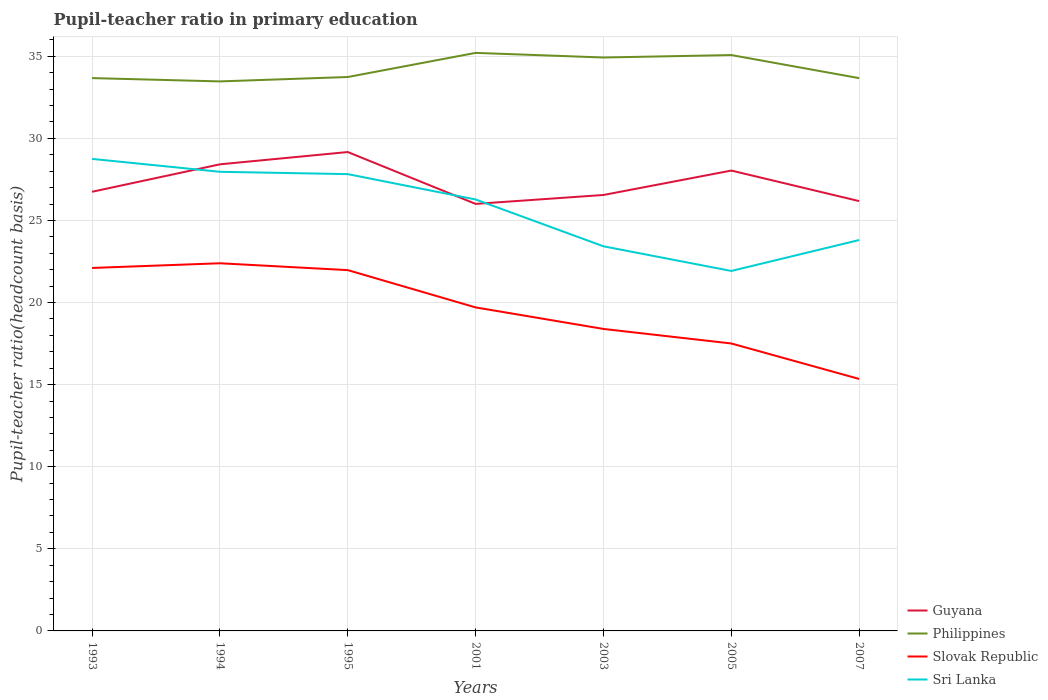Is the number of lines equal to the number of legend labels?
Ensure brevity in your answer.  Yes. Across all years, what is the maximum pupil-teacher ratio in primary education in Philippines?
Provide a short and direct response. 33.47. In which year was the pupil-teacher ratio in primary education in Philippines maximum?
Provide a short and direct response. 1994. What is the total pupil-teacher ratio in primary education in Guyana in the graph?
Your answer should be very brief. 0.19. What is the difference between the highest and the second highest pupil-teacher ratio in primary education in Sri Lanka?
Offer a very short reply. 6.83. What is the difference between the highest and the lowest pupil-teacher ratio in primary education in Philippines?
Ensure brevity in your answer.  3. Does the graph contain any zero values?
Offer a very short reply. No. Does the graph contain grids?
Provide a short and direct response. Yes. How are the legend labels stacked?
Give a very brief answer. Vertical. What is the title of the graph?
Provide a short and direct response. Pupil-teacher ratio in primary education. Does "Bahamas" appear as one of the legend labels in the graph?
Keep it short and to the point. No. What is the label or title of the Y-axis?
Your answer should be compact. Pupil-teacher ratio(headcount basis). What is the Pupil-teacher ratio(headcount basis) of Guyana in 1993?
Your answer should be very brief. 26.75. What is the Pupil-teacher ratio(headcount basis) of Philippines in 1993?
Ensure brevity in your answer.  33.67. What is the Pupil-teacher ratio(headcount basis) in Slovak Republic in 1993?
Offer a terse response. 22.11. What is the Pupil-teacher ratio(headcount basis) in Sri Lanka in 1993?
Provide a succinct answer. 28.75. What is the Pupil-teacher ratio(headcount basis) of Guyana in 1994?
Provide a succinct answer. 28.42. What is the Pupil-teacher ratio(headcount basis) in Philippines in 1994?
Your answer should be compact. 33.47. What is the Pupil-teacher ratio(headcount basis) of Slovak Republic in 1994?
Give a very brief answer. 22.39. What is the Pupil-teacher ratio(headcount basis) of Sri Lanka in 1994?
Give a very brief answer. 27.96. What is the Pupil-teacher ratio(headcount basis) of Guyana in 1995?
Offer a terse response. 29.17. What is the Pupil-teacher ratio(headcount basis) of Philippines in 1995?
Make the answer very short. 33.74. What is the Pupil-teacher ratio(headcount basis) of Slovak Republic in 1995?
Provide a succinct answer. 21.98. What is the Pupil-teacher ratio(headcount basis) of Sri Lanka in 1995?
Your answer should be compact. 27.82. What is the Pupil-teacher ratio(headcount basis) of Guyana in 2001?
Make the answer very short. 26.01. What is the Pupil-teacher ratio(headcount basis) of Philippines in 2001?
Ensure brevity in your answer.  35.21. What is the Pupil-teacher ratio(headcount basis) of Slovak Republic in 2001?
Give a very brief answer. 19.7. What is the Pupil-teacher ratio(headcount basis) in Sri Lanka in 2001?
Offer a very short reply. 26.28. What is the Pupil-teacher ratio(headcount basis) in Guyana in 2003?
Offer a terse response. 26.55. What is the Pupil-teacher ratio(headcount basis) of Philippines in 2003?
Your answer should be compact. 34.93. What is the Pupil-teacher ratio(headcount basis) of Slovak Republic in 2003?
Your response must be concise. 18.39. What is the Pupil-teacher ratio(headcount basis) in Sri Lanka in 2003?
Your answer should be compact. 23.43. What is the Pupil-teacher ratio(headcount basis) in Guyana in 2005?
Give a very brief answer. 28.04. What is the Pupil-teacher ratio(headcount basis) of Philippines in 2005?
Make the answer very short. 35.07. What is the Pupil-teacher ratio(headcount basis) in Slovak Republic in 2005?
Provide a succinct answer. 17.51. What is the Pupil-teacher ratio(headcount basis) in Sri Lanka in 2005?
Provide a succinct answer. 21.92. What is the Pupil-teacher ratio(headcount basis) of Guyana in 2007?
Ensure brevity in your answer.  26.18. What is the Pupil-teacher ratio(headcount basis) in Philippines in 2007?
Provide a short and direct response. 33.67. What is the Pupil-teacher ratio(headcount basis) in Slovak Republic in 2007?
Make the answer very short. 15.35. What is the Pupil-teacher ratio(headcount basis) of Sri Lanka in 2007?
Give a very brief answer. 23.81. Across all years, what is the maximum Pupil-teacher ratio(headcount basis) in Guyana?
Offer a terse response. 29.17. Across all years, what is the maximum Pupil-teacher ratio(headcount basis) in Philippines?
Offer a very short reply. 35.21. Across all years, what is the maximum Pupil-teacher ratio(headcount basis) of Slovak Republic?
Offer a very short reply. 22.39. Across all years, what is the maximum Pupil-teacher ratio(headcount basis) of Sri Lanka?
Keep it short and to the point. 28.75. Across all years, what is the minimum Pupil-teacher ratio(headcount basis) in Guyana?
Provide a short and direct response. 26.01. Across all years, what is the minimum Pupil-teacher ratio(headcount basis) in Philippines?
Your answer should be very brief. 33.47. Across all years, what is the minimum Pupil-teacher ratio(headcount basis) in Slovak Republic?
Your response must be concise. 15.35. Across all years, what is the minimum Pupil-teacher ratio(headcount basis) in Sri Lanka?
Keep it short and to the point. 21.92. What is the total Pupil-teacher ratio(headcount basis) in Guyana in the graph?
Your answer should be compact. 191.11. What is the total Pupil-teacher ratio(headcount basis) in Philippines in the graph?
Provide a succinct answer. 239.75. What is the total Pupil-teacher ratio(headcount basis) of Slovak Republic in the graph?
Provide a short and direct response. 137.43. What is the total Pupil-teacher ratio(headcount basis) in Sri Lanka in the graph?
Make the answer very short. 179.97. What is the difference between the Pupil-teacher ratio(headcount basis) of Guyana in 1993 and that in 1994?
Give a very brief answer. -1.67. What is the difference between the Pupil-teacher ratio(headcount basis) in Philippines in 1993 and that in 1994?
Your answer should be compact. 0.2. What is the difference between the Pupil-teacher ratio(headcount basis) of Slovak Republic in 1993 and that in 1994?
Your answer should be very brief. -0.29. What is the difference between the Pupil-teacher ratio(headcount basis) in Sri Lanka in 1993 and that in 1994?
Ensure brevity in your answer.  0.79. What is the difference between the Pupil-teacher ratio(headcount basis) of Guyana in 1993 and that in 1995?
Your answer should be compact. -2.42. What is the difference between the Pupil-teacher ratio(headcount basis) of Philippines in 1993 and that in 1995?
Make the answer very short. -0.07. What is the difference between the Pupil-teacher ratio(headcount basis) in Slovak Republic in 1993 and that in 1995?
Keep it short and to the point. 0.13. What is the difference between the Pupil-teacher ratio(headcount basis) of Sri Lanka in 1993 and that in 1995?
Your response must be concise. 0.93. What is the difference between the Pupil-teacher ratio(headcount basis) of Guyana in 1993 and that in 2001?
Your answer should be compact. 0.74. What is the difference between the Pupil-teacher ratio(headcount basis) in Philippines in 1993 and that in 2001?
Ensure brevity in your answer.  -1.54. What is the difference between the Pupil-teacher ratio(headcount basis) of Slovak Republic in 1993 and that in 2001?
Ensure brevity in your answer.  2.4. What is the difference between the Pupil-teacher ratio(headcount basis) in Sri Lanka in 1993 and that in 2001?
Your response must be concise. 2.47. What is the difference between the Pupil-teacher ratio(headcount basis) in Guyana in 1993 and that in 2003?
Your answer should be very brief. 0.19. What is the difference between the Pupil-teacher ratio(headcount basis) of Philippines in 1993 and that in 2003?
Give a very brief answer. -1.25. What is the difference between the Pupil-teacher ratio(headcount basis) in Slovak Republic in 1993 and that in 2003?
Offer a very short reply. 3.71. What is the difference between the Pupil-teacher ratio(headcount basis) in Sri Lanka in 1993 and that in 2003?
Ensure brevity in your answer.  5.32. What is the difference between the Pupil-teacher ratio(headcount basis) of Guyana in 1993 and that in 2005?
Provide a succinct answer. -1.29. What is the difference between the Pupil-teacher ratio(headcount basis) of Philippines in 1993 and that in 2005?
Your answer should be very brief. -1.4. What is the difference between the Pupil-teacher ratio(headcount basis) in Slovak Republic in 1993 and that in 2005?
Offer a terse response. 4.6. What is the difference between the Pupil-teacher ratio(headcount basis) in Sri Lanka in 1993 and that in 2005?
Your response must be concise. 6.83. What is the difference between the Pupil-teacher ratio(headcount basis) of Guyana in 1993 and that in 2007?
Keep it short and to the point. 0.57. What is the difference between the Pupil-teacher ratio(headcount basis) in Philippines in 1993 and that in 2007?
Ensure brevity in your answer.  0. What is the difference between the Pupil-teacher ratio(headcount basis) of Slovak Republic in 1993 and that in 2007?
Your response must be concise. 6.76. What is the difference between the Pupil-teacher ratio(headcount basis) in Sri Lanka in 1993 and that in 2007?
Ensure brevity in your answer.  4.94. What is the difference between the Pupil-teacher ratio(headcount basis) of Guyana in 1994 and that in 1995?
Your response must be concise. -0.75. What is the difference between the Pupil-teacher ratio(headcount basis) in Philippines in 1994 and that in 1995?
Ensure brevity in your answer.  -0.27. What is the difference between the Pupil-teacher ratio(headcount basis) of Slovak Republic in 1994 and that in 1995?
Give a very brief answer. 0.42. What is the difference between the Pupil-teacher ratio(headcount basis) of Sri Lanka in 1994 and that in 1995?
Ensure brevity in your answer.  0.14. What is the difference between the Pupil-teacher ratio(headcount basis) in Guyana in 1994 and that in 2001?
Provide a short and direct response. 2.41. What is the difference between the Pupil-teacher ratio(headcount basis) of Philippines in 1994 and that in 2001?
Keep it short and to the point. -1.74. What is the difference between the Pupil-teacher ratio(headcount basis) in Slovak Republic in 1994 and that in 2001?
Ensure brevity in your answer.  2.69. What is the difference between the Pupil-teacher ratio(headcount basis) in Sri Lanka in 1994 and that in 2001?
Your answer should be very brief. 1.69. What is the difference between the Pupil-teacher ratio(headcount basis) in Guyana in 1994 and that in 2003?
Ensure brevity in your answer.  1.87. What is the difference between the Pupil-teacher ratio(headcount basis) in Philippines in 1994 and that in 2003?
Give a very brief answer. -1.46. What is the difference between the Pupil-teacher ratio(headcount basis) in Slovak Republic in 1994 and that in 2003?
Your answer should be compact. 4. What is the difference between the Pupil-teacher ratio(headcount basis) in Sri Lanka in 1994 and that in 2003?
Give a very brief answer. 4.54. What is the difference between the Pupil-teacher ratio(headcount basis) of Guyana in 1994 and that in 2005?
Keep it short and to the point. 0.38. What is the difference between the Pupil-teacher ratio(headcount basis) of Philippines in 1994 and that in 2005?
Give a very brief answer. -1.6. What is the difference between the Pupil-teacher ratio(headcount basis) of Slovak Republic in 1994 and that in 2005?
Offer a very short reply. 4.89. What is the difference between the Pupil-teacher ratio(headcount basis) of Sri Lanka in 1994 and that in 2005?
Offer a terse response. 6.04. What is the difference between the Pupil-teacher ratio(headcount basis) in Guyana in 1994 and that in 2007?
Your response must be concise. 2.24. What is the difference between the Pupil-teacher ratio(headcount basis) in Philippines in 1994 and that in 2007?
Make the answer very short. -0.2. What is the difference between the Pupil-teacher ratio(headcount basis) in Slovak Republic in 1994 and that in 2007?
Make the answer very short. 7.05. What is the difference between the Pupil-teacher ratio(headcount basis) of Sri Lanka in 1994 and that in 2007?
Provide a short and direct response. 4.16. What is the difference between the Pupil-teacher ratio(headcount basis) of Guyana in 1995 and that in 2001?
Give a very brief answer. 3.16. What is the difference between the Pupil-teacher ratio(headcount basis) in Philippines in 1995 and that in 2001?
Your answer should be compact. -1.47. What is the difference between the Pupil-teacher ratio(headcount basis) in Slovak Republic in 1995 and that in 2001?
Your answer should be very brief. 2.27. What is the difference between the Pupil-teacher ratio(headcount basis) of Sri Lanka in 1995 and that in 2001?
Give a very brief answer. 1.54. What is the difference between the Pupil-teacher ratio(headcount basis) in Guyana in 1995 and that in 2003?
Ensure brevity in your answer.  2.62. What is the difference between the Pupil-teacher ratio(headcount basis) of Philippines in 1995 and that in 2003?
Your answer should be very brief. -1.19. What is the difference between the Pupil-teacher ratio(headcount basis) in Slovak Republic in 1995 and that in 2003?
Keep it short and to the point. 3.58. What is the difference between the Pupil-teacher ratio(headcount basis) in Sri Lanka in 1995 and that in 2003?
Provide a short and direct response. 4.4. What is the difference between the Pupil-teacher ratio(headcount basis) of Guyana in 1995 and that in 2005?
Offer a very short reply. 1.13. What is the difference between the Pupil-teacher ratio(headcount basis) in Philippines in 1995 and that in 2005?
Your answer should be very brief. -1.34. What is the difference between the Pupil-teacher ratio(headcount basis) in Slovak Republic in 1995 and that in 2005?
Your answer should be compact. 4.47. What is the difference between the Pupil-teacher ratio(headcount basis) of Sri Lanka in 1995 and that in 2005?
Keep it short and to the point. 5.9. What is the difference between the Pupil-teacher ratio(headcount basis) of Guyana in 1995 and that in 2007?
Your response must be concise. 2.99. What is the difference between the Pupil-teacher ratio(headcount basis) in Philippines in 1995 and that in 2007?
Make the answer very short. 0.07. What is the difference between the Pupil-teacher ratio(headcount basis) of Slovak Republic in 1995 and that in 2007?
Give a very brief answer. 6.63. What is the difference between the Pupil-teacher ratio(headcount basis) in Sri Lanka in 1995 and that in 2007?
Offer a terse response. 4.01. What is the difference between the Pupil-teacher ratio(headcount basis) of Guyana in 2001 and that in 2003?
Provide a short and direct response. -0.54. What is the difference between the Pupil-teacher ratio(headcount basis) of Philippines in 2001 and that in 2003?
Make the answer very short. 0.28. What is the difference between the Pupil-teacher ratio(headcount basis) in Slovak Republic in 2001 and that in 2003?
Your answer should be compact. 1.31. What is the difference between the Pupil-teacher ratio(headcount basis) in Sri Lanka in 2001 and that in 2003?
Offer a terse response. 2.85. What is the difference between the Pupil-teacher ratio(headcount basis) of Guyana in 2001 and that in 2005?
Your response must be concise. -2.03. What is the difference between the Pupil-teacher ratio(headcount basis) of Philippines in 2001 and that in 2005?
Your answer should be compact. 0.13. What is the difference between the Pupil-teacher ratio(headcount basis) of Slovak Republic in 2001 and that in 2005?
Offer a terse response. 2.2. What is the difference between the Pupil-teacher ratio(headcount basis) in Sri Lanka in 2001 and that in 2005?
Provide a succinct answer. 4.35. What is the difference between the Pupil-teacher ratio(headcount basis) in Guyana in 2001 and that in 2007?
Make the answer very short. -0.17. What is the difference between the Pupil-teacher ratio(headcount basis) of Philippines in 2001 and that in 2007?
Give a very brief answer. 1.54. What is the difference between the Pupil-teacher ratio(headcount basis) of Slovak Republic in 2001 and that in 2007?
Provide a succinct answer. 4.36. What is the difference between the Pupil-teacher ratio(headcount basis) in Sri Lanka in 2001 and that in 2007?
Provide a succinct answer. 2.47. What is the difference between the Pupil-teacher ratio(headcount basis) of Guyana in 2003 and that in 2005?
Offer a very short reply. -1.49. What is the difference between the Pupil-teacher ratio(headcount basis) of Philippines in 2003 and that in 2005?
Your response must be concise. -0.15. What is the difference between the Pupil-teacher ratio(headcount basis) of Slovak Republic in 2003 and that in 2005?
Provide a succinct answer. 0.89. What is the difference between the Pupil-teacher ratio(headcount basis) of Sri Lanka in 2003 and that in 2005?
Your response must be concise. 1.5. What is the difference between the Pupil-teacher ratio(headcount basis) of Guyana in 2003 and that in 2007?
Give a very brief answer. 0.37. What is the difference between the Pupil-teacher ratio(headcount basis) in Philippines in 2003 and that in 2007?
Provide a short and direct response. 1.26. What is the difference between the Pupil-teacher ratio(headcount basis) of Slovak Republic in 2003 and that in 2007?
Offer a terse response. 3.05. What is the difference between the Pupil-teacher ratio(headcount basis) of Sri Lanka in 2003 and that in 2007?
Offer a very short reply. -0.38. What is the difference between the Pupil-teacher ratio(headcount basis) of Guyana in 2005 and that in 2007?
Make the answer very short. 1.86. What is the difference between the Pupil-teacher ratio(headcount basis) in Philippines in 2005 and that in 2007?
Give a very brief answer. 1.41. What is the difference between the Pupil-teacher ratio(headcount basis) of Slovak Republic in 2005 and that in 2007?
Your response must be concise. 2.16. What is the difference between the Pupil-teacher ratio(headcount basis) in Sri Lanka in 2005 and that in 2007?
Ensure brevity in your answer.  -1.88. What is the difference between the Pupil-teacher ratio(headcount basis) in Guyana in 1993 and the Pupil-teacher ratio(headcount basis) in Philippines in 1994?
Your answer should be compact. -6.72. What is the difference between the Pupil-teacher ratio(headcount basis) of Guyana in 1993 and the Pupil-teacher ratio(headcount basis) of Slovak Republic in 1994?
Provide a short and direct response. 4.35. What is the difference between the Pupil-teacher ratio(headcount basis) of Guyana in 1993 and the Pupil-teacher ratio(headcount basis) of Sri Lanka in 1994?
Your answer should be very brief. -1.22. What is the difference between the Pupil-teacher ratio(headcount basis) of Philippines in 1993 and the Pupil-teacher ratio(headcount basis) of Slovak Republic in 1994?
Offer a very short reply. 11.28. What is the difference between the Pupil-teacher ratio(headcount basis) in Philippines in 1993 and the Pupil-teacher ratio(headcount basis) in Sri Lanka in 1994?
Offer a very short reply. 5.71. What is the difference between the Pupil-teacher ratio(headcount basis) in Slovak Republic in 1993 and the Pupil-teacher ratio(headcount basis) in Sri Lanka in 1994?
Provide a succinct answer. -5.86. What is the difference between the Pupil-teacher ratio(headcount basis) in Guyana in 1993 and the Pupil-teacher ratio(headcount basis) in Philippines in 1995?
Offer a terse response. -6.99. What is the difference between the Pupil-teacher ratio(headcount basis) of Guyana in 1993 and the Pupil-teacher ratio(headcount basis) of Slovak Republic in 1995?
Give a very brief answer. 4.77. What is the difference between the Pupil-teacher ratio(headcount basis) in Guyana in 1993 and the Pupil-teacher ratio(headcount basis) in Sri Lanka in 1995?
Provide a succinct answer. -1.08. What is the difference between the Pupil-teacher ratio(headcount basis) of Philippines in 1993 and the Pupil-teacher ratio(headcount basis) of Slovak Republic in 1995?
Make the answer very short. 11.7. What is the difference between the Pupil-teacher ratio(headcount basis) in Philippines in 1993 and the Pupil-teacher ratio(headcount basis) in Sri Lanka in 1995?
Give a very brief answer. 5.85. What is the difference between the Pupil-teacher ratio(headcount basis) in Slovak Republic in 1993 and the Pupil-teacher ratio(headcount basis) in Sri Lanka in 1995?
Provide a short and direct response. -5.71. What is the difference between the Pupil-teacher ratio(headcount basis) of Guyana in 1993 and the Pupil-teacher ratio(headcount basis) of Philippines in 2001?
Your response must be concise. -8.46. What is the difference between the Pupil-teacher ratio(headcount basis) in Guyana in 1993 and the Pupil-teacher ratio(headcount basis) in Slovak Republic in 2001?
Make the answer very short. 7.04. What is the difference between the Pupil-teacher ratio(headcount basis) of Guyana in 1993 and the Pupil-teacher ratio(headcount basis) of Sri Lanka in 2001?
Keep it short and to the point. 0.47. What is the difference between the Pupil-teacher ratio(headcount basis) in Philippines in 1993 and the Pupil-teacher ratio(headcount basis) in Slovak Republic in 2001?
Offer a terse response. 13.97. What is the difference between the Pupil-teacher ratio(headcount basis) in Philippines in 1993 and the Pupil-teacher ratio(headcount basis) in Sri Lanka in 2001?
Your answer should be very brief. 7.39. What is the difference between the Pupil-teacher ratio(headcount basis) of Slovak Republic in 1993 and the Pupil-teacher ratio(headcount basis) of Sri Lanka in 2001?
Your response must be concise. -4.17. What is the difference between the Pupil-teacher ratio(headcount basis) in Guyana in 1993 and the Pupil-teacher ratio(headcount basis) in Philippines in 2003?
Provide a succinct answer. -8.18. What is the difference between the Pupil-teacher ratio(headcount basis) of Guyana in 1993 and the Pupil-teacher ratio(headcount basis) of Slovak Republic in 2003?
Make the answer very short. 8.35. What is the difference between the Pupil-teacher ratio(headcount basis) of Guyana in 1993 and the Pupil-teacher ratio(headcount basis) of Sri Lanka in 2003?
Your response must be concise. 3.32. What is the difference between the Pupil-teacher ratio(headcount basis) in Philippines in 1993 and the Pupil-teacher ratio(headcount basis) in Slovak Republic in 2003?
Provide a short and direct response. 15.28. What is the difference between the Pupil-teacher ratio(headcount basis) in Philippines in 1993 and the Pupil-teacher ratio(headcount basis) in Sri Lanka in 2003?
Provide a short and direct response. 10.24. What is the difference between the Pupil-teacher ratio(headcount basis) of Slovak Republic in 1993 and the Pupil-teacher ratio(headcount basis) of Sri Lanka in 2003?
Ensure brevity in your answer.  -1.32. What is the difference between the Pupil-teacher ratio(headcount basis) in Guyana in 1993 and the Pupil-teacher ratio(headcount basis) in Philippines in 2005?
Your response must be concise. -8.33. What is the difference between the Pupil-teacher ratio(headcount basis) in Guyana in 1993 and the Pupil-teacher ratio(headcount basis) in Slovak Republic in 2005?
Ensure brevity in your answer.  9.24. What is the difference between the Pupil-teacher ratio(headcount basis) in Guyana in 1993 and the Pupil-teacher ratio(headcount basis) in Sri Lanka in 2005?
Keep it short and to the point. 4.82. What is the difference between the Pupil-teacher ratio(headcount basis) of Philippines in 1993 and the Pupil-teacher ratio(headcount basis) of Slovak Republic in 2005?
Ensure brevity in your answer.  16.16. What is the difference between the Pupil-teacher ratio(headcount basis) of Philippines in 1993 and the Pupil-teacher ratio(headcount basis) of Sri Lanka in 2005?
Your response must be concise. 11.75. What is the difference between the Pupil-teacher ratio(headcount basis) in Slovak Republic in 1993 and the Pupil-teacher ratio(headcount basis) in Sri Lanka in 2005?
Offer a very short reply. 0.18. What is the difference between the Pupil-teacher ratio(headcount basis) of Guyana in 1993 and the Pupil-teacher ratio(headcount basis) of Philippines in 2007?
Keep it short and to the point. -6.92. What is the difference between the Pupil-teacher ratio(headcount basis) in Guyana in 1993 and the Pupil-teacher ratio(headcount basis) in Slovak Republic in 2007?
Make the answer very short. 11.4. What is the difference between the Pupil-teacher ratio(headcount basis) of Guyana in 1993 and the Pupil-teacher ratio(headcount basis) of Sri Lanka in 2007?
Keep it short and to the point. 2.94. What is the difference between the Pupil-teacher ratio(headcount basis) in Philippines in 1993 and the Pupil-teacher ratio(headcount basis) in Slovak Republic in 2007?
Your answer should be very brief. 18.32. What is the difference between the Pupil-teacher ratio(headcount basis) of Philippines in 1993 and the Pupil-teacher ratio(headcount basis) of Sri Lanka in 2007?
Provide a succinct answer. 9.86. What is the difference between the Pupil-teacher ratio(headcount basis) of Slovak Republic in 1993 and the Pupil-teacher ratio(headcount basis) of Sri Lanka in 2007?
Your answer should be very brief. -1.7. What is the difference between the Pupil-teacher ratio(headcount basis) in Guyana in 1994 and the Pupil-teacher ratio(headcount basis) in Philippines in 1995?
Your answer should be compact. -5.32. What is the difference between the Pupil-teacher ratio(headcount basis) of Guyana in 1994 and the Pupil-teacher ratio(headcount basis) of Slovak Republic in 1995?
Your answer should be compact. 6.44. What is the difference between the Pupil-teacher ratio(headcount basis) of Guyana in 1994 and the Pupil-teacher ratio(headcount basis) of Sri Lanka in 1995?
Your answer should be very brief. 0.6. What is the difference between the Pupil-teacher ratio(headcount basis) of Philippines in 1994 and the Pupil-teacher ratio(headcount basis) of Slovak Republic in 1995?
Your answer should be compact. 11.49. What is the difference between the Pupil-teacher ratio(headcount basis) of Philippines in 1994 and the Pupil-teacher ratio(headcount basis) of Sri Lanka in 1995?
Make the answer very short. 5.65. What is the difference between the Pupil-teacher ratio(headcount basis) in Slovak Republic in 1994 and the Pupil-teacher ratio(headcount basis) in Sri Lanka in 1995?
Keep it short and to the point. -5.43. What is the difference between the Pupil-teacher ratio(headcount basis) of Guyana in 1994 and the Pupil-teacher ratio(headcount basis) of Philippines in 2001?
Make the answer very short. -6.79. What is the difference between the Pupil-teacher ratio(headcount basis) of Guyana in 1994 and the Pupil-teacher ratio(headcount basis) of Slovak Republic in 2001?
Make the answer very short. 8.72. What is the difference between the Pupil-teacher ratio(headcount basis) of Guyana in 1994 and the Pupil-teacher ratio(headcount basis) of Sri Lanka in 2001?
Provide a succinct answer. 2.14. What is the difference between the Pupil-teacher ratio(headcount basis) in Philippines in 1994 and the Pupil-teacher ratio(headcount basis) in Slovak Republic in 2001?
Your response must be concise. 13.77. What is the difference between the Pupil-teacher ratio(headcount basis) of Philippines in 1994 and the Pupil-teacher ratio(headcount basis) of Sri Lanka in 2001?
Provide a short and direct response. 7.19. What is the difference between the Pupil-teacher ratio(headcount basis) in Slovak Republic in 1994 and the Pupil-teacher ratio(headcount basis) in Sri Lanka in 2001?
Provide a short and direct response. -3.89. What is the difference between the Pupil-teacher ratio(headcount basis) of Guyana in 1994 and the Pupil-teacher ratio(headcount basis) of Philippines in 2003?
Offer a terse response. -6.51. What is the difference between the Pupil-teacher ratio(headcount basis) in Guyana in 1994 and the Pupil-teacher ratio(headcount basis) in Slovak Republic in 2003?
Ensure brevity in your answer.  10.03. What is the difference between the Pupil-teacher ratio(headcount basis) in Guyana in 1994 and the Pupil-teacher ratio(headcount basis) in Sri Lanka in 2003?
Offer a terse response. 4.99. What is the difference between the Pupil-teacher ratio(headcount basis) of Philippines in 1994 and the Pupil-teacher ratio(headcount basis) of Slovak Republic in 2003?
Provide a succinct answer. 15.08. What is the difference between the Pupil-teacher ratio(headcount basis) in Philippines in 1994 and the Pupil-teacher ratio(headcount basis) in Sri Lanka in 2003?
Make the answer very short. 10.04. What is the difference between the Pupil-teacher ratio(headcount basis) in Slovak Republic in 1994 and the Pupil-teacher ratio(headcount basis) in Sri Lanka in 2003?
Offer a very short reply. -1.03. What is the difference between the Pupil-teacher ratio(headcount basis) in Guyana in 1994 and the Pupil-teacher ratio(headcount basis) in Philippines in 2005?
Provide a short and direct response. -6.65. What is the difference between the Pupil-teacher ratio(headcount basis) of Guyana in 1994 and the Pupil-teacher ratio(headcount basis) of Slovak Republic in 2005?
Make the answer very short. 10.91. What is the difference between the Pupil-teacher ratio(headcount basis) of Guyana in 1994 and the Pupil-teacher ratio(headcount basis) of Sri Lanka in 2005?
Your answer should be compact. 6.5. What is the difference between the Pupil-teacher ratio(headcount basis) in Philippines in 1994 and the Pupil-teacher ratio(headcount basis) in Slovak Republic in 2005?
Make the answer very short. 15.96. What is the difference between the Pupil-teacher ratio(headcount basis) in Philippines in 1994 and the Pupil-teacher ratio(headcount basis) in Sri Lanka in 2005?
Your answer should be very brief. 11.55. What is the difference between the Pupil-teacher ratio(headcount basis) in Slovak Republic in 1994 and the Pupil-teacher ratio(headcount basis) in Sri Lanka in 2005?
Your response must be concise. 0.47. What is the difference between the Pupil-teacher ratio(headcount basis) in Guyana in 1994 and the Pupil-teacher ratio(headcount basis) in Philippines in 2007?
Your answer should be very brief. -5.25. What is the difference between the Pupil-teacher ratio(headcount basis) of Guyana in 1994 and the Pupil-teacher ratio(headcount basis) of Slovak Republic in 2007?
Offer a terse response. 13.07. What is the difference between the Pupil-teacher ratio(headcount basis) in Guyana in 1994 and the Pupil-teacher ratio(headcount basis) in Sri Lanka in 2007?
Your response must be concise. 4.61. What is the difference between the Pupil-teacher ratio(headcount basis) in Philippines in 1994 and the Pupil-teacher ratio(headcount basis) in Slovak Republic in 2007?
Offer a terse response. 18.12. What is the difference between the Pupil-teacher ratio(headcount basis) of Philippines in 1994 and the Pupil-teacher ratio(headcount basis) of Sri Lanka in 2007?
Provide a short and direct response. 9.66. What is the difference between the Pupil-teacher ratio(headcount basis) of Slovak Republic in 1994 and the Pupil-teacher ratio(headcount basis) of Sri Lanka in 2007?
Provide a short and direct response. -1.41. What is the difference between the Pupil-teacher ratio(headcount basis) of Guyana in 1995 and the Pupil-teacher ratio(headcount basis) of Philippines in 2001?
Offer a very short reply. -6.04. What is the difference between the Pupil-teacher ratio(headcount basis) of Guyana in 1995 and the Pupil-teacher ratio(headcount basis) of Slovak Republic in 2001?
Your answer should be very brief. 9.46. What is the difference between the Pupil-teacher ratio(headcount basis) of Guyana in 1995 and the Pupil-teacher ratio(headcount basis) of Sri Lanka in 2001?
Your answer should be very brief. 2.89. What is the difference between the Pupil-teacher ratio(headcount basis) of Philippines in 1995 and the Pupil-teacher ratio(headcount basis) of Slovak Republic in 2001?
Your answer should be very brief. 14.03. What is the difference between the Pupil-teacher ratio(headcount basis) in Philippines in 1995 and the Pupil-teacher ratio(headcount basis) in Sri Lanka in 2001?
Ensure brevity in your answer.  7.46. What is the difference between the Pupil-teacher ratio(headcount basis) in Slovak Republic in 1995 and the Pupil-teacher ratio(headcount basis) in Sri Lanka in 2001?
Provide a succinct answer. -4.3. What is the difference between the Pupil-teacher ratio(headcount basis) of Guyana in 1995 and the Pupil-teacher ratio(headcount basis) of Philippines in 2003?
Your answer should be compact. -5.76. What is the difference between the Pupil-teacher ratio(headcount basis) of Guyana in 1995 and the Pupil-teacher ratio(headcount basis) of Slovak Republic in 2003?
Provide a succinct answer. 10.77. What is the difference between the Pupil-teacher ratio(headcount basis) of Guyana in 1995 and the Pupil-teacher ratio(headcount basis) of Sri Lanka in 2003?
Provide a succinct answer. 5.74. What is the difference between the Pupil-teacher ratio(headcount basis) of Philippines in 1995 and the Pupil-teacher ratio(headcount basis) of Slovak Republic in 2003?
Offer a very short reply. 15.34. What is the difference between the Pupil-teacher ratio(headcount basis) in Philippines in 1995 and the Pupil-teacher ratio(headcount basis) in Sri Lanka in 2003?
Offer a terse response. 10.31. What is the difference between the Pupil-teacher ratio(headcount basis) in Slovak Republic in 1995 and the Pupil-teacher ratio(headcount basis) in Sri Lanka in 2003?
Keep it short and to the point. -1.45. What is the difference between the Pupil-teacher ratio(headcount basis) in Guyana in 1995 and the Pupil-teacher ratio(headcount basis) in Philippines in 2005?
Provide a succinct answer. -5.91. What is the difference between the Pupil-teacher ratio(headcount basis) of Guyana in 1995 and the Pupil-teacher ratio(headcount basis) of Slovak Republic in 2005?
Make the answer very short. 11.66. What is the difference between the Pupil-teacher ratio(headcount basis) of Guyana in 1995 and the Pupil-teacher ratio(headcount basis) of Sri Lanka in 2005?
Provide a succinct answer. 7.24. What is the difference between the Pupil-teacher ratio(headcount basis) of Philippines in 1995 and the Pupil-teacher ratio(headcount basis) of Slovak Republic in 2005?
Provide a succinct answer. 16.23. What is the difference between the Pupil-teacher ratio(headcount basis) in Philippines in 1995 and the Pupil-teacher ratio(headcount basis) in Sri Lanka in 2005?
Keep it short and to the point. 11.81. What is the difference between the Pupil-teacher ratio(headcount basis) in Slovak Republic in 1995 and the Pupil-teacher ratio(headcount basis) in Sri Lanka in 2005?
Your answer should be compact. 0.05. What is the difference between the Pupil-teacher ratio(headcount basis) of Guyana in 1995 and the Pupil-teacher ratio(headcount basis) of Philippines in 2007?
Your answer should be compact. -4.5. What is the difference between the Pupil-teacher ratio(headcount basis) of Guyana in 1995 and the Pupil-teacher ratio(headcount basis) of Slovak Republic in 2007?
Make the answer very short. 13.82. What is the difference between the Pupil-teacher ratio(headcount basis) of Guyana in 1995 and the Pupil-teacher ratio(headcount basis) of Sri Lanka in 2007?
Your answer should be compact. 5.36. What is the difference between the Pupil-teacher ratio(headcount basis) of Philippines in 1995 and the Pupil-teacher ratio(headcount basis) of Slovak Republic in 2007?
Your response must be concise. 18.39. What is the difference between the Pupil-teacher ratio(headcount basis) of Philippines in 1995 and the Pupil-teacher ratio(headcount basis) of Sri Lanka in 2007?
Keep it short and to the point. 9.93. What is the difference between the Pupil-teacher ratio(headcount basis) of Slovak Republic in 1995 and the Pupil-teacher ratio(headcount basis) of Sri Lanka in 2007?
Provide a short and direct response. -1.83. What is the difference between the Pupil-teacher ratio(headcount basis) of Guyana in 2001 and the Pupil-teacher ratio(headcount basis) of Philippines in 2003?
Provide a short and direct response. -8.92. What is the difference between the Pupil-teacher ratio(headcount basis) of Guyana in 2001 and the Pupil-teacher ratio(headcount basis) of Slovak Republic in 2003?
Give a very brief answer. 7.62. What is the difference between the Pupil-teacher ratio(headcount basis) of Guyana in 2001 and the Pupil-teacher ratio(headcount basis) of Sri Lanka in 2003?
Your answer should be compact. 2.58. What is the difference between the Pupil-teacher ratio(headcount basis) of Philippines in 2001 and the Pupil-teacher ratio(headcount basis) of Slovak Republic in 2003?
Your answer should be compact. 16.81. What is the difference between the Pupil-teacher ratio(headcount basis) of Philippines in 2001 and the Pupil-teacher ratio(headcount basis) of Sri Lanka in 2003?
Offer a terse response. 11.78. What is the difference between the Pupil-teacher ratio(headcount basis) in Slovak Republic in 2001 and the Pupil-teacher ratio(headcount basis) in Sri Lanka in 2003?
Your response must be concise. -3.72. What is the difference between the Pupil-teacher ratio(headcount basis) in Guyana in 2001 and the Pupil-teacher ratio(headcount basis) in Philippines in 2005?
Keep it short and to the point. -9.06. What is the difference between the Pupil-teacher ratio(headcount basis) in Guyana in 2001 and the Pupil-teacher ratio(headcount basis) in Slovak Republic in 2005?
Offer a very short reply. 8.5. What is the difference between the Pupil-teacher ratio(headcount basis) in Guyana in 2001 and the Pupil-teacher ratio(headcount basis) in Sri Lanka in 2005?
Ensure brevity in your answer.  4.09. What is the difference between the Pupil-teacher ratio(headcount basis) in Philippines in 2001 and the Pupil-teacher ratio(headcount basis) in Slovak Republic in 2005?
Make the answer very short. 17.7. What is the difference between the Pupil-teacher ratio(headcount basis) of Philippines in 2001 and the Pupil-teacher ratio(headcount basis) of Sri Lanka in 2005?
Offer a very short reply. 13.28. What is the difference between the Pupil-teacher ratio(headcount basis) in Slovak Republic in 2001 and the Pupil-teacher ratio(headcount basis) in Sri Lanka in 2005?
Your response must be concise. -2.22. What is the difference between the Pupil-teacher ratio(headcount basis) in Guyana in 2001 and the Pupil-teacher ratio(headcount basis) in Philippines in 2007?
Make the answer very short. -7.66. What is the difference between the Pupil-teacher ratio(headcount basis) of Guyana in 2001 and the Pupil-teacher ratio(headcount basis) of Slovak Republic in 2007?
Provide a succinct answer. 10.66. What is the difference between the Pupil-teacher ratio(headcount basis) in Guyana in 2001 and the Pupil-teacher ratio(headcount basis) in Sri Lanka in 2007?
Provide a short and direct response. 2.2. What is the difference between the Pupil-teacher ratio(headcount basis) in Philippines in 2001 and the Pupil-teacher ratio(headcount basis) in Slovak Republic in 2007?
Provide a short and direct response. 19.86. What is the difference between the Pupil-teacher ratio(headcount basis) in Philippines in 2001 and the Pupil-teacher ratio(headcount basis) in Sri Lanka in 2007?
Make the answer very short. 11.4. What is the difference between the Pupil-teacher ratio(headcount basis) in Slovak Republic in 2001 and the Pupil-teacher ratio(headcount basis) in Sri Lanka in 2007?
Make the answer very short. -4.1. What is the difference between the Pupil-teacher ratio(headcount basis) in Guyana in 2003 and the Pupil-teacher ratio(headcount basis) in Philippines in 2005?
Offer a very short reply. -8.52. What is the difference between the Pupil-teacher ratio(headcount basis) of Guyana in 2003 and the Pupil-teacher ratio(headcount basis) of Slovak Republic in 2005?
Your answer should be compact. 9.04. What is the difference between the Pupil-teacher ratio(headcount basis) of Guyana in 2003 and the Pupil-teacher ratio(headcount basis) of Sri Lanka in 2005?
Make the answer very short. 4.63. What is the difference between the Pupil-teacher ratio(headcount basis) in Philippines in 2003 and the Pupil-teacher ratio(headcount basis) in Slovak Republic in 2005?
Ensure brevity in your answer.  17.42. What is the difference between the Pupil-teacher ratio(headcount basis) of Philippines in 2003 and the Pupil-teacher ratio(headcount basis) of Sri Lanka in 2005?
Provide a succinct answer. 13. What is the difference between the Pupil-teacher ratio(headcount basis) in Slovak Republic in 2003 and the Pupil-teacher ratio(headcount basis) in Sri Lanka in 2005?
Your answer should be very brief. -3.53. What is the difference between the Pupil-teacher ratio(headcount basis) in Guyana in 2003 and the Pupil-teacher ratio(headcount basis) in Philippines in 2007?
Provide a short and direct response. -7.12. What is the difference between the Pupil-teacher ratio(headcount basis) in Guyana in 2003 and the Pupil-teacher ratio(headcount basis) in Slovak Republic in 2007?
Make the answer very short. 11.21. What is the difference between the Pupil-teacher ratio(headcount basis) of Guyana in 2003 and the Pupil-teacher ratio(headcount basis) of Sri Lanka in 2007?
Your answer should be very brief. 2.74. What is the difference between the Pupil-teacher ratio(headcount basis) in Philippines in 2003 and the Pupil-teacher ratio(headcount basis) in Slovak Republic in 2007?
Ensure brevity in your answer.  19.58. What is the difference between the Pupil-teacher ratio(headcount basis) of Philippines in 2003 and the Pupil-teacher ratio(headcount basis) of Sri Lanka in 2007?
Your response must be concise. 11.12. What is the difference between the Pupil-teacher ratio(headcount basis) of Slovak Republic in 2003 and the Pupil-teacher ratio(headcount basis) of Sri Lanka in 2007?
Provide a short and direct response. -5.41. What is the difference between the Pupil-teacher ratio(headcount basis) in Guyana in 2005 and the Pupil-teacher ratio(headcount basis) in Philippines in 2007?
Provide a succinct answer. -5.63. What is the difference between the Pupil-teacher ratio(headcount basis) in Guyana in 2005 and the Pupil-teacher ratio(headcount basis) in Slovak Republic in 2007?
Your response must be concise. 12.69. What is the difference between the Pupil-teacher ratio(headcount basis) in Guyana in 2005 and the Pupil-teacher ratio(headcount basis) in Sri Lanka in 2007?
Provide a succinct answer. 4.23. What is the difference between the Pupil-teacher ratio(headcount basis) in Philippines in 2005 and the Pupil-teacher ratio(headcount basis) in Slovak Republic in 2007?
Offer a terse response. 19.73. What is the difference between the Pupil-teacher ratio(headcount basis) in Philippines in 2005 and the Pupil-teacher ratio(headcount basis) in Sri Lanka in 2007?
Make the answer very short. 11.27. What is the difference between the Pupil-teacher ratio(headcount basis) of Slovak Republic in 2005 and the Pupil-teacher ratio(headcount basis) of Sri Lanka in 2007?
Make the answer very short. -6.3. What is the average Pupil-teacher ratio(headcount basis) in Guyana per year?
Offer a terse response. 27.3. What is the average Pupil-teacher ratio(headcount basis) in Philippines per year?
Ensure brevity in your answer.  34.25. What is the average Pupil-teacher ratio(headcount basis) in Slovak Republic per year?
Your answer should be compact. 19.63. What is the average Pupil-teacher ratio(headcount basis) of Sri Lanka per year?
Give a very brief answer. 25.71. In the year 1993, what is the difference between the Pupil-teacher ratio(headcount basis) in Guyana and Pupil-teacher ratio(headcount basis) in Philippines?
Offer a terse response. -6.92. In the year 1993, what is the difference between the Pupil-teacher ratio(headcount basis) in Guyana and Pupil-teacher ratio(headcount basis) in Slovak Republic?
Ensure brevity in your answer.  4.64. In the year 1993, what is the difference between the Pupil-teacher ratio(headcount basis) of Guyana and Pupil-teacher ratio(headcount basis) of Sri Lanka?
Ensure brevity in your answer.  -2. In the year 1993, what is the difference between the Pupil-teacher ratio(headcount basis) of Philippines and Pupil-teacher ratio(headcount basis) of Slovak Republic?
Your response must be concise. 11.56. In the year 1993, what is the difference between the Pupil-teacher ratio(headcount basis) in Philippines and Pupil-teacher ratio(headcount basis) in Sri Lanka?
Offer a terse response. 4.92. In the year 1993, what is the difference between the Pupil-teacher ratio(headcount basis) in Slovak Republic and Pupil-teacher ratio(headcount basis) in Sri Lanka?
Your answer should be compact. -6.64. In the year 1994, what is the difference between the Pupil-teacher ratio(headcount basis) of Guyana and Pupil-teacher ratio(headcount basis) of Philippines?
Your answer should be compact. -5.05. In the year 1994, what is the difference between the Pupil-teacher ratio(headcount basis) in Guyana and Pupil-teacher ratio(headcount basis) in Slovak Republic?
Make the answer very short. 6.03. In the year 1994, what is the difference between the Pupil-teacher ratio(headcount basis) of Guyana and Pupil-teacher ratio(headcount basis) of Sri Lanka?
Your answer should be compact. 0.46. In the year 1994, what is the difference between the Pupil-teacher ratio(headcount basis) of Philippines and Pupil-teacher ratio(headcount basis) of Slovak Republic?
Keep it short and to the point. 11.08. In the year 1994, what is the difference between the Pupil-teacher ratio(headcount basis) in Philippines and Pupil-teacher ratio(headcount basis) in Sri Lanka?
Provide a short and direct response. 5.51. In the year 1994, what is the difference between the Pupil-teacher ratio(headcount basis) of Slovak Republic and Pupil-teacher ratio(headcount basis) of Sri Lanka?
Make the answer very short. -5.57. In the year 1995, what is the difference between the Pupil-teacher ratio(headcount basis) of Guyana and Pupil-teacher ratio(headcount basis) of Philippines?
Provide a succinct answer. -4.57. In the year 1995, what is the difference between the Pupil-teacher ratio(headcount basis) of Guyana and Pupil-teacher ratio(headcount basis) of Slovak Republic?
Your response must be concise. 7.19. In the year 1995, what is the difference between the Pupil-teacher ratio(headcount basis) in Guyana and Pupil-teacher ratio(headcount basis) in Sri Lanka?
Give a very brief answer. 1.34. In the year 1995, what is the difference between the Pupil-teacher ratio(headcount basis) of Philippines and Pupil-teacher ratio(headcount basis) of Slovak Republic?
Provide a short and direct response. 11.76. In the year 1995, what is the difference between the Pupil-teacher ratio(headcount basis) in Philippines and Pupil-teacher ratio(headcount basis) in Sri Lanka?
Offer a terse response. 5.91. In the year 1995, what is the difference between the Pupil-teacher ratio(headcount basis) of Slovak Republic and Pupil-teacher ratio(headcount basis) of Sri Lanka?
Your response must be concise. -5.85. In the year 2001, what is the difference between the Pupil-teacher ratio(headcount basis) of Guyana and Pupil-teacher ratio(headcount basis) of Philippines?
Offer a very short reply. -9.2. In the year 2001, what is the difference between the Pupil-teacher ratio(headcount basis) of Guyana and Pupil-teacher ratio(headcount basis) of Slovak Republic?
Offer a very short reply. 6.31. In the year 2001, what is the difference between the Pupil-teacher ratio(headcount basis) in Guyana and Pupil-teacher ratio(headcount basis) in Sri Lanka?
Your response must be concise. -0.27. In the year 2001, what is the difference between the Pupil-teacher ratio(headcount basis) in Philippines and Pupil-teacher ratio(headcount basis) in Slovak Republic?
Your answer should be compact. 15.5. In the year 2001, what is the difference between the Pupil-teacher ratio(headcount basis) in Philippines and Pupil-teacher ratio(headcount basis) in Sri Lanka?
Offer a very short reply. 8.93. In the year 2001, what is the difference between the Pupil-teacher ratio(headcount basis) in Slovak Republic and Pupil-teacher ratio(headcount basis) in Sri Lanka?
Your answer should be compact. -6.58. In the year 2003, what is the difference between the Pupil-teacher ratio(headcount basis) of Guyana and Pupil-teacher ratio(headcount basis) of Philippines?
Your response must be concise. -8.37. In the year 2003, what is the difference between the Pupil-teacher ratio(headcount basis) in Guyana and Pupil-teacher ratio(headcount basis) in Slovak Republic?
Ensure brevity in your answer.  8.16. In the year 2003, what is the difference between the Pupil-teacher ratio(headcount basis) of Guyana and Pupil-teacher ratio(headcount basis) of Sri Lanka?
Give a very brief answer. 3.13. In the year 2003, what is the difference between the Pupil-teacher ratio(headcount basis) of Philippines and Pupil-teacher ratio(headcount basis) of Slovak Republic?
Make the answer very short. 16.53. In the year 2003, what is the difference between the Pupil-teacher ratio(headcount basis) of Philippines and Pupil-teacher ratio(headcount basis) of Sri Lanka?
Offer a very short reply. 11.5. In the year 2003, what is the difference between the Pupil-teacher ratio(headcount basis) in Slovak Republic and Pupil-teacher ratio(headcount basis) in Sri Lanka?
Your response must be concise. -5.03. In the year 2005, what is the difference between the Pupil-teacher ratio(headcount basis) in Guyana and Pupil-teacher ratio(headcount basis) in Philippines?
Ensure brevity in your answer.  -7.03. In the year 2005, what is the difference between the Pupil-teacher ratio(headcount basis) of Guyana and Pupil-teacher ratio(headcount basis) of Slovak Republic?
Provide a succinct answer. 10.53. In the year 2005, what is the difference between the Pupil-teacher ratio(headcount basis) of Guyana and Pupil-teacher ratio(headcount basis) of Sri Lanka?
Your answer should be compact. 6.12. In the year 2005, what is the difference between the Pupil-teacher ratio(headcount basis) in Philippines and Pupil-teacher ratio(headcount basis) in Slovak Republic?
Make the answer very short. 17.57. In the year 2005, what is the difference between the Pupil-teacher ratio(headcount basis) of Philippines and Pupil-teacher ratio(headcount basis) of Sri Lanka?
Make the answer very short. 13.15. In the year 2005, what is the difference between the Pupil-teacher ratio(headcount basis) in Slovak Republic and Pupil-teacher ratio(headcount basis) in Sri Lanka?
Your response must be concise. -4.42. In the year 2007, what is the difference between the Pupil-teacher ratio(headcount basis) in Guyana and Pupil-teacher ratio(headcount basis) in Philippines?
Give a very brief answer. -7.49. In the year 2007, what is the difference between the Pupil-teacher ratio(headcount basis) of Guyana and Pupil-teacher ratio(headcount basis) of Slovak Republic?
Ensure brevity in your answer.  10.83. In the year 2007, what is the difference between the Pupil-teacher ratio(headcount basis) of Guyana and Pupil-teacher ratio(headcount basis) of Sri Lanka?
Offer a terse response. 2.37. In the year 2007, what is the difference between the Pupil-teacher ratio(headcount basis) in Philippines and Pupil-teacher ratio(headcount basis) in Slovak Republic?
Provide a short and direct response. 18.32. In the year 2007, what is the difference between the Pupil-teacher ratio(headcount basis) in Philippines and Pupil-teacher ratio(headcount basis) in Sri Lanka?
Your response must be concise. 9.86. In the year 2007, what is the difference between the Pupil-teacher ratio(headcount basis) in Slovak Republic and Pupil-teacher ratio(headcount basis) in Sri Lanka?
Your response must be concise. -8.46. What is the ratio of the Pupil-teacher ratio(headcount basis) of Guyana in 1993 to that in 1994?
Provide a succinct answer. 0.94. What is the ratio of the Pupil-teacher ratio(headcount basis) in Philippines in 1993 to that in 1994?
Make the answer very short. 1.01. What is the ratio of the Pupil-teacher ratio(headcount basis) in Slovak Republic in 1993 to that in 1994?
Provide a short and direct response. 0.99. What is the ratio of the Pupil-teacher ratio(headcount basis) of Sri Lanka in 1993 to that in 1994?
Ensure brevity in your answer.  1.03. What is the ratio of the Pupil-teacher ratio(headcount basis) in Guyana in 1993 to that in 1995?
Ensure brevity in your answer.  0.92. What is the ratio of the Pupil-teacher ratio(headcount basis) in Sri Lanka in 1993 to that in 1995?
Provide a short and direct response. 1.03. What is the ratio of the Pupil-teacher ratio(headcount basis) in Guyana in 1993 to that in 2001?
Provide a short and direct response. 1.03. What is the ratio of the Pupil-teacher ratio(headcount basis) of Philippines in 1993 to that in 2001?
Offer a terse response. 0.96. What is the ratio of the Pupil-teacher ratio(headcount basis) in Slovak Republic in 1993 to that in 2001?
Ensure brevity in your answer.  1.12. What is the ratio of the Pupil-teacher ratio(headcount basis) in Sri Lanka in 1993 to that in 2001?
Your response must be concise. 1.09. What is the ratio of the Pupil-teacher ratio(headcount basis) in Guyana in 1993 to that in 2003?
Provide a short and direct response. 1.01. What is the ratio of the Pupil-teacher ratio(headcount basis) in Philippines in 1993 to that in 2003?
Provide a short and direct response. 0.96. What is the ratio of the Pupil-teacher ratio(headcount basis) of Slovak Republic in 1993 to that in 2003?
Keep it short and to the point. 1.2. What is the ratio of the Pupil-teacher ratio(headcount basis) in Sri Lanka in 1993 to that in 2003?
Give a very brief answer. 1.23. What is the ratio of the Pupil-teacher ratio(headcount basis) of Guyana in 1993 to that in 2005?
Offer a very short reply. 0.95. What is the ratio of the Pupil-teacher ratio(headcount basis) of Slovak Republic in 1993 to that in 2005?
Ensure brevity in your answer.  1.26. What is the ratio of the Pupil-teacher ratio(headcount basis) in Sri Lanka in 1993 to that in 2005?
Ensure brevity in your answer.  1.31. What is the ratio of the Pupil-teacher ratio(headcount basis) in Guyana in 1993 to that in 2007?
Ensure brevity in your answer.  1.02. What is the ratio of the Pupil-teacher ratio(headcount basis) of Philippines in 1993 to that in 2007?
Provide a short and direct response. 1. What is the ratio of the Pupil-teacher ratio(headcount basis) of Slovak Republic in 1993 to that in 2007?
Provide a short and direct response. 1.44. What is the ratio of the Pupil-teacher ratio(headcount basis) of Sri Lanka in 1993 to that in 2007?
Offer a terse response. 1.21. What is the ratio of the Pupil-teacher ratio(headcount basis) of Guyana in 1994 to that in 1995?
Ensure brevity in your answer.  0.97. What is the ratio of the Pupil-teacher ratio(headcount basis) of Philippines in 1994 to that in 1995?
Make the answer very short. 0.99. What is the ratio of the Pupil-teacher ratio(headcount basis) in Slovak Republic in 1994 to that in 1995?
Your answer should be very brief. 1.02. What is the ratio of the Pupil-teacher ratio(headcount basis) of Guyana in 1994 to that in 2001?
Keep it short and to the point. 1.09. What is the ratio of the Pupil-teacher ratio(headcount basis) in Philippines in 1994 to that in 2001?
Your answer should be very brief. 0.95. What is the ratio of the Pupil-teacher ratio(headcount basis) of Slovak Republic in 1994 to that in 2001?
Your answer should be very brief. 1.14. What is the ratio of the Pupil-teacher ratio(headcount basis) in Sri Lanka in 1994 to that in 2001?
Your answer should be compact. 1.06. What is the ratio of the Pupil-teacher ratio(headcount basis) in Guyana in 1994 to that in 2003?
Make the answer very short. 1.07. What is the ratio of the Pupil-teacher ratio(headcount basis) in Philippines in 1994 to that in 2003?
Offer a terse response. 0.96. What is the ratio of the Pupil-teacher ratio(headcount basis) of Slovak Republic in 1994 to that in 2003?
Provide a short and direct response. 1.22. What is the ratio of the Pupil-teacher ratio(headcount basis) in Sri Lanka in 1994 to that in 2003?
Ensure brevity in your answer.  1.19. What is the ratio of the Pupil-teacher ratio(headcount basis) in Guyana in 1994 to that in 2005?
Provide a succinct answer. 1.01. What is the ratio of the Pupil-teacher ratio(headcount basis) in Philippines in 1994 to that in 2005?
Make the answer very short. 0.95. What is the ratio of the Pupil-teacher ratio(headcount basis) in Slovak Republic in 1994 to that in 2005?
Offer a very short reply. 1.28. What is the ratio of the Pupil-teacher ratio(headcount basis) of Sri Lanka in 1994 to that in 2005?
Offer a terse response. 1.28. What is the ratio of the Pupil-teacher ratio(headcount basis) in Guyana in 1994 to that in 2007?
Offer a terse response. 1.09. What is the ratio of the Pupil-teacher ratio(headcount basis) in Slovak Republic in 1994 to that in 2007?
Offer a terse response. 1.46. What is the ratio of the Pupil-teacher ratio(headcount basis) in Sri Lanka in 1994 to that in 2007?
Keep it short and to the point. 1.17. What is the ratio of the Pupil-teacher ratio(headcount basis) in Guyana in 1995 to that in 2001?
Provide a succinct answer. 1.12. What is the ratio of the Pupil-teacher ratio(headcount basis) in Philippines in 1995 to that in 2001?
Make the answer very short. 0.96. What is the ratio of the Pupil-teacher ratio(headcount basis) in Slovak Republic in 1995 to that in 2001?
Make the answer very short. 1.12. What is the ratio of the Pupil-teacher ratio(headcount basis) in Sri Lanka in 1995 to that in 2001?
Your answer should be compact. 1.06. What is the ratio of the Pupil-teacher ratio(headcount basis) in Guyana in 1995 to that in 2003?
Your answer should be compact. 1.1. What is the ratio of the Pupil-teacher ratio(headcount basis) of Slovak Republic in 1995 to that in 2003?
Your answer should be very brief. 1.19. What is the ratio of the Pupil-teacher ratio(headcount basis) in Sri Lanka in 1995 to that in 2003?
Offer a very short reply. 1.19. What is the ratio of the Pupil-teacher ratio(headcount basis) of Guyana in 1995 to that in 2005?
Provide a succinct answer. 1.04. What is the ratio of the Pupil-teacher ratio(headcount basis) in Philippines in 1995 to that in 2005?
Your answer should be compact. 0.96. What is the ratio of the Pupil-teacher ratio(headcount basis) of Slovak Republic in 1995 to that in 2005?
Offer a very short reply. 1.26. What is the ratio of the Pupil-teacher ratio(headcount basis) of Sri Lanka in 1995 to that in 2005?
Your answer should be very brief. 1.27. What is the ratio of the Pupil-teacher ratio(headcount basis) in Guyana in 1995 to that in 2007?
Your response must be concise. 1.11. What is the ratio of the Pupil-teacher ratio(headcount basis) of Slovak Republic in 1995 to that in 2007?
Ensure brevity in your answer.  1.43. What is the ratio of the Pupil-teacher ratio(headcount basis) in Sri Lanka in 1995 to that in 2007?
Keep it short and to the point. 1.17. What is the ratio of the Pupil-teacher ratio(headcount basis) of Guyana in 2001 to that in 2003?
Ensure brevity in your answer.  0.98. What is the ratio of the Pupil-teacher ratio(headcount basis) in Philippines in 2001 to that in 2003?
Make the answer very short. 1.01. What is the ratio of the Pupil-teacher ratio(headcount basis) in Slovak Republic in 2001 to that in 2003?
Offer a very short reply. 1.07. What is the ratio of the Pupil-teacher ratio(headcount basis) of Sri Lanka in 2001 to that in 2003?
Your answer should be very brief. 1.12. What is the ratio of the Pupil-teacher ratio(headcount basis) in Guyana in 2001 to that in 2005?
Your response must be concise. 0.93. What is the ratio of the Pupil-teacher ratio(headcount basis) of Philippines in 2001 to that in 2005?
Your response must be concise. 1. What is the ratio of the Pupil-teacher ratio(headcount basis) in Slovak Republic in 2001 to that in 2005?
Provide a succinct answer. 1.13. What is the ratio of the Pupil-teacher ratio(headcount basis) in Sri Lanka in 2001 to that in 2005?
Keep it short and to the point. 1.2. What is the ratio of the Pupil-teacher ratio(headcount basis) in Philippines in 2001 to that in 2007?
Your response must be concise. 1.05. What is the ratio of the Pupil-teacher ratio(headcount basis) of Slovak Republic in 2001 to that in 2007?
Make the answer very short. 1.28. What is the ratio of the Pupil-teacher ratio(headcount basis) in Sri Lanka in 2001 to that in 2007?
Make the answer very short. 1.1. What is the ratio of the Pupil-teacher ratio(headcount basis) in Guyana in 2003 to that in 2005?
Keep it short and to the point. 0.95. What is the ratio of the Pupil-teacher ratio(headcount basis) of Slovak Republic in 2003 to that in 2005?
Make the answer very short. 1.05. What is the ratio of the Pupil-teacher ratio(headcount basis) in Sri Lanka in 2003 to that in 2005?
Offer a very short reply. 1.07. What is the ratio of the Pupil-teacher ratio(headcount basis) of Guyana in 2003 to that in 2007?
Your answer should be compact. 1.01. What is the ratio of the Pupil-teacher ratio(headcount basis) in Philippines in 2003 to that in 2007?
Ensure brevity in your answer.  1.04. What is the ratio of the Pupil-teacher ratio(headcount basis) of Slovak Republic in 2003 to that in 2007?
Offer a very short reply. 1.2. What is the ratio of the Pupil-teacher ratio(headcount basis) in Guyana in 2005 to that in 2007?
Make the answer very short. 1.07. What is the ratio of the Pupil-teacher ratio(headcount basis) of Philippines in 2005 to that in 2007?
Ensure brevity in your answer.  1.04. What is the ratio of the Pupil-teacher ratio(headcount basis) of Slovak Republic in 2005 to that in 2007?
Offer a terse response. 1.14. What is the ratio of the Pupil-teacher ratio(headcount basis) of Sri Lanka in 2005 to that in 2007?
Provide a succinct answer. 0.92. What is the difference between the highest and the second highest Pupil-teacher ratio(headcount basis) of Guyana?
Your answer should be compact. 0.75. What is the difference between the highest and the second highest Pupil-teacher ratio(headcount basis) of Philippines?
Your answer should be very brief. 0.13. What is the difference between the highest and the second highest Pupil-teacher ratio(headcount basis) in Slovak Republic?
Your answer should be very brief. 0.29. What is the difference between the highest and the second highest Pupil-teacher ratio(headcount basis) in Sri Lanka?
Provide a succinct answer. 0.79. What is the difference between the highest and the lowest Pupil-teacher ratio(headcount basis) of Guyana?
Your answer should be very brief. 3.16. What is the difference between the highest and the lowest Pupil-teacher ratio(headcount basis) in Philippines?
Ensure brevity in your answer.  1.74. What is the difference between the highest and the lowest Pupil-teacher ratio(headcount basis) of Slovak Republic?
Offer a very short reply. 7.05. What is the difference between the highest and the lowest Pupil-teacher ratio(headcount basis) in Sri Lanka?
Keep it short and to the point. 6.83. 